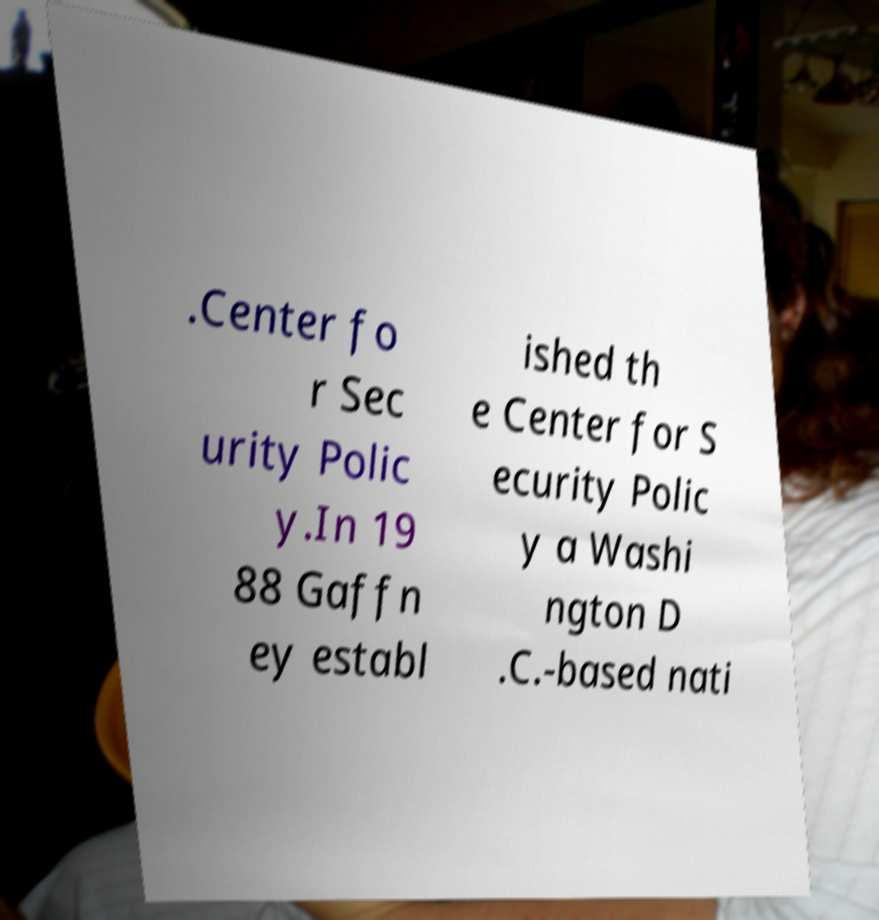Could you assist in decoding the text presented in this image and type it out clearly? .Center fo r Sec urity Polic y.In 19 88 Gaffn ey establ ished th e Center for S ecurity Polic y a Washi ngton D .C.-based nati 